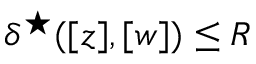Convert formula to latex. <formula><loc_0><loc_0><loc_500><loc_500>{ \delta ^ { ^ { * } } ( [ z ] , [ w ] ) \leq R }</formula> 